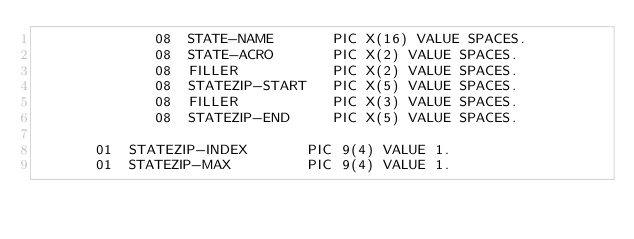<code> <loc_0><loc_0><loc_500><loc_500><_COBOL_>              08  STATE-NAME       PIC X(16) VALUE SPACES.
              08  STATE-ACRO       PIC X(2) VALUE SPACES.
              08  FILLER           PIC X(2) VALUE SPACES.
              08  STATEZIP-START   PIC X(5) VALUE SPACES.
              08  FILLER           PIC X(3) VALUE SPACES.
              08  STATEZIP-END     PIC X(5) VALUE SPACES.

       01  STATEZIP-INDEX       PIC 9(4) VALUE 1.
       01  STATEZIP-MAX         PIC 9(4) VALUE 1.
</code> 